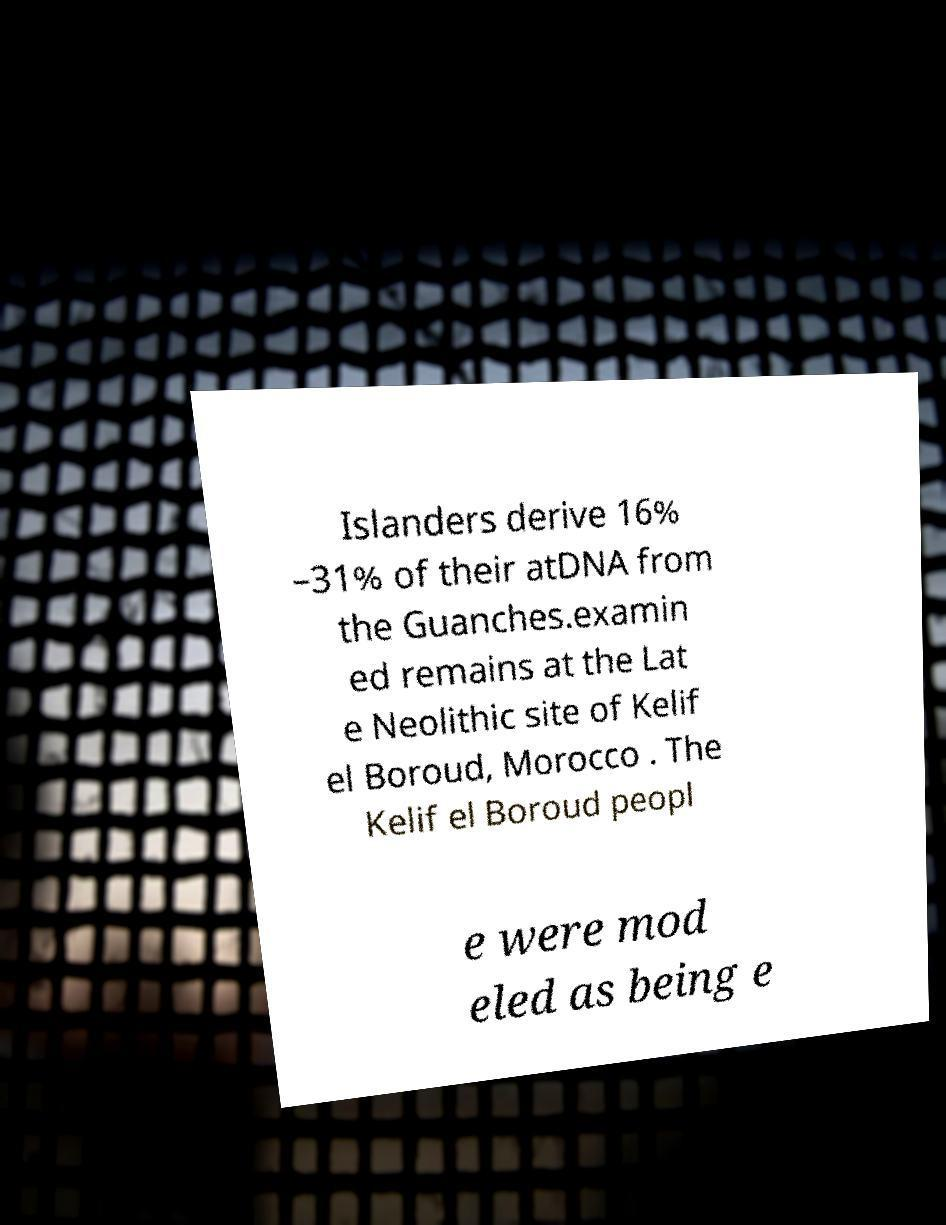Can you accurately transcribe the text from the provided image for me? Islanders derive 16% –31% of their atDNA from the Guanches.examin ed remains at the Lat e Neolithic site of Kelif el Boroud, Morocco . The Kelif el Boroud peopl e were mod eled as being e 